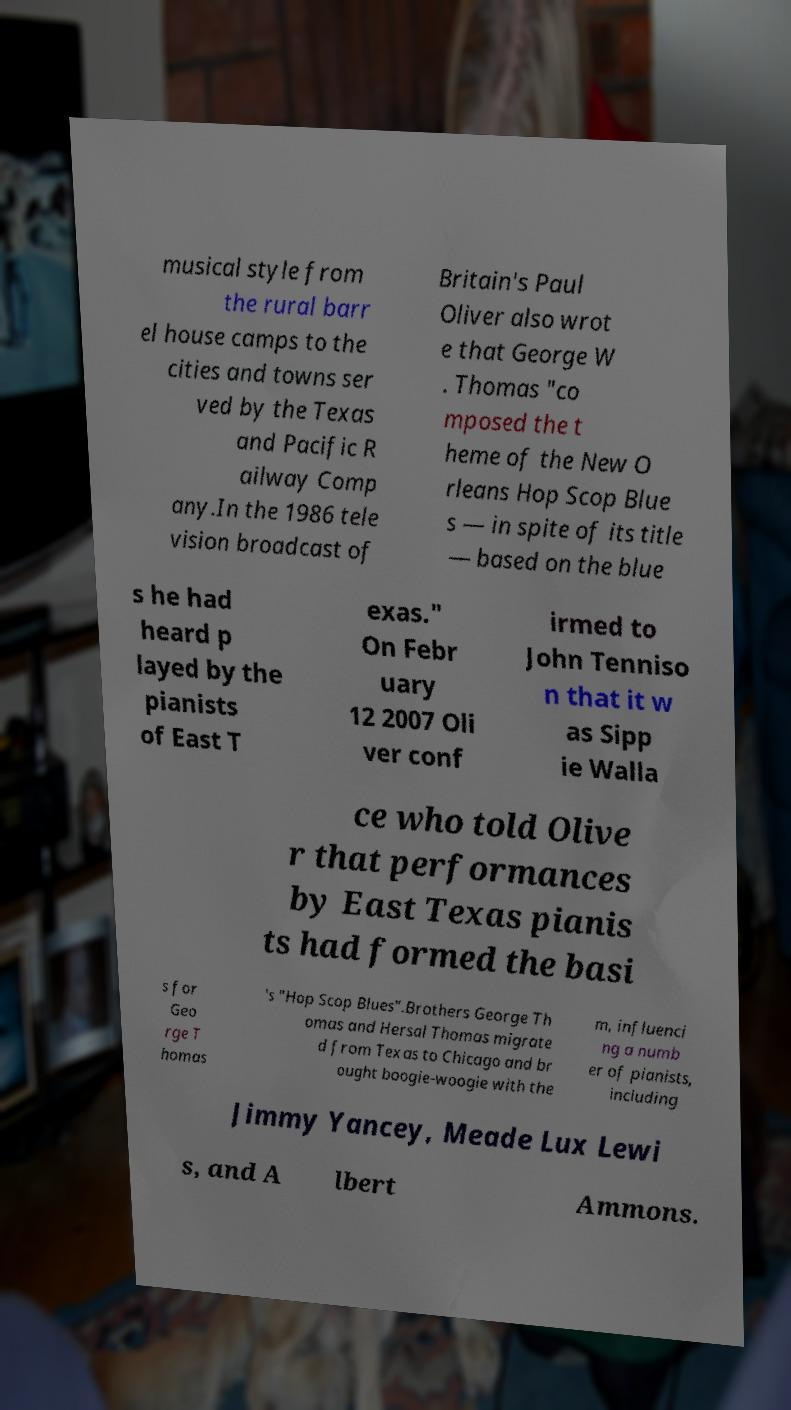Please read and relay the text visible in this image. What does it say? musical style from the rural barr el house camps to the cities and towns ser ved by the Texas and Pacific R ailway Comp any.In the 1986 tele vision broadcast of Britain's Paul Oliver also wrot e that George W . Thomas "co mposed the t heme of the New O rleans Hop Scop Blue s — in spite of its title — based on the blue s he had heard p layed by the pianists of East T exas." On Febr uary 12 2007 Oli ver conf irmed to John Tenniso n that it w as Sipp ie Walla ce who told Olive r that performances by East Texas pianis ts had formed the basi s for Geo rge T homas 's "Hop Scop Blues".Brothers George Th omas and Hersal Thomas migrate d from Texas to Chicago and br ought boogie-woogie with the m, influenci ng a numb er of pianists, including Jimmy Yancey, Meade Lux Lewi s, and A lbert Ammons. 